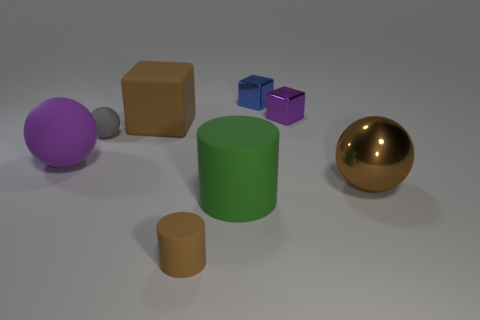What material is the big sphere that is the same color as the big rubber block?
Give a very brief answer. Metal. What is the material of the sphere right of the thing that is behind the purple thing on the right side of the big brown rubber cube?
Ensure brevity in your answer.  Metal. What size is the block that is both in front of the blue thing and on the left side of the small purple shiny block?
Provide a succinct answer. Large. What number of cylinders are either large cyan shiny things or gray objects?
Offer a terse response. 0. What color is the cylinder that is the same size as the rubber cube?
Your answer should be very brief. Green. Are there any other things that have the same shape as the tiny gray object?
Offer a very short reply. Yes. What is the color of the other big rubber object that is the same shape as the gray rubber object?
Provide a short and direct response. Purple. How many things are green matte objects or big rubber objects left of the brown rubber cylinder?
Your answer should be compact. 3. Is the number of brown objects in front of the big block less than the number of big green matte spheres?
Offer a terse response. No. How big is the brown object that is behind the big brown object on the right side of the matte object in front of the large green object?
Provide a short and direct response. Large. 